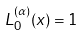<formula> <loc_0><loc_0><loc_500><loc_500>L _ { 0 } ^ { ( \alpha ) } ( x ) = 1</formula> 